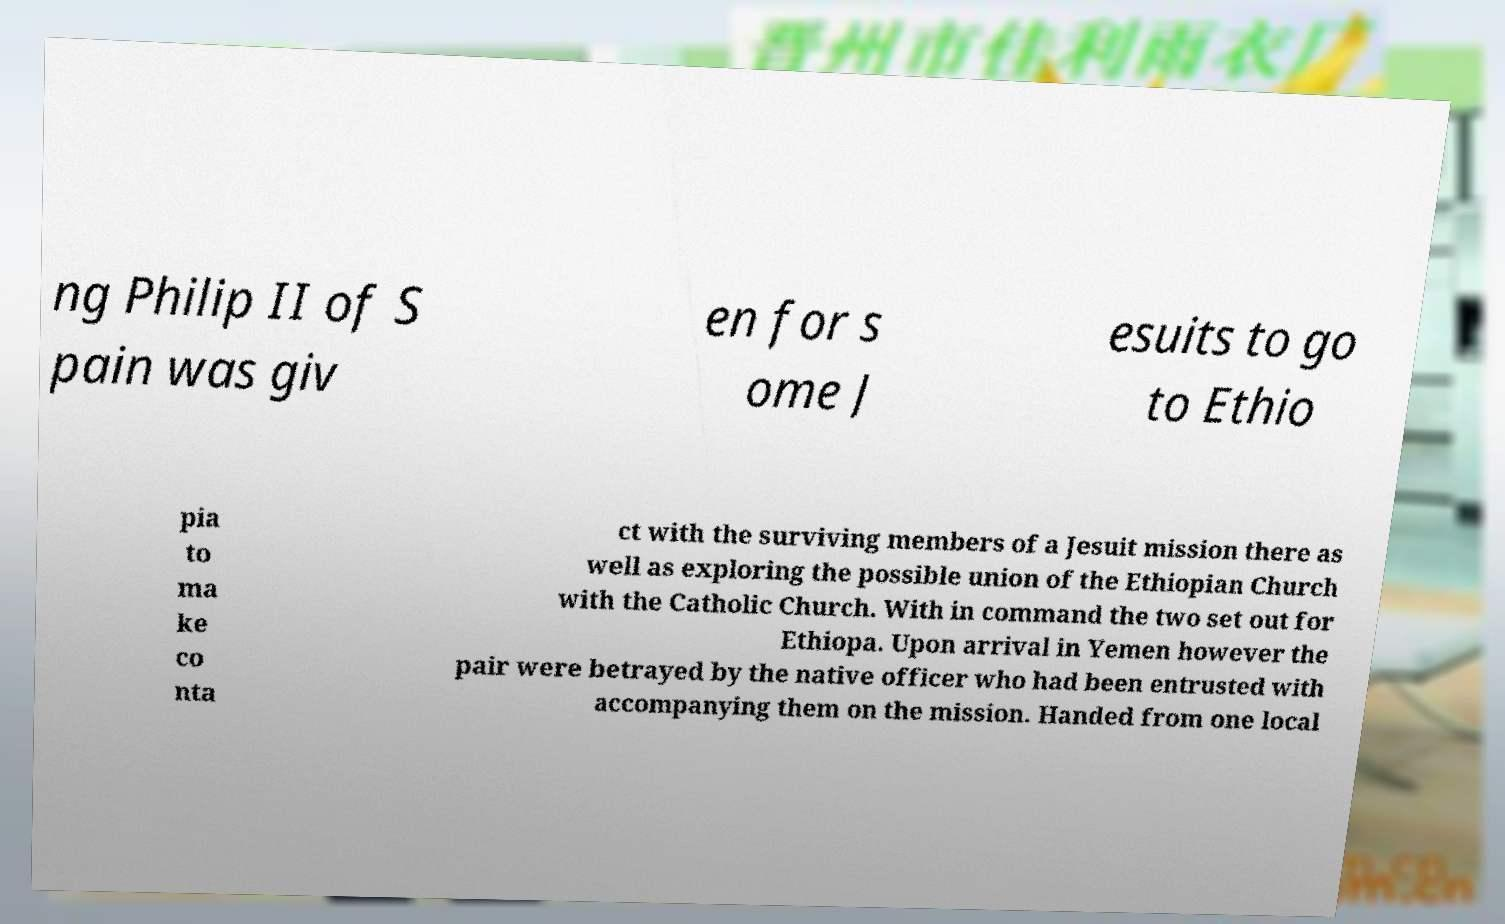For documentation purposes, I need the text within this image transcribed. Could you provide that? ng Philip II of S pain was giv en for s ome J esuits to go to Ethio pia to ma ke co nta ct with the surviving members of a Jesuit mission there as well as exploring the possible union of the Ethiopian Church with the Catholic Church. With in command the two set out for Ethiopa. Upon arrival in Yemen however the pair were betrayed by the native officer who had been entrusted with accompanying them on the mission. Handed from one local 